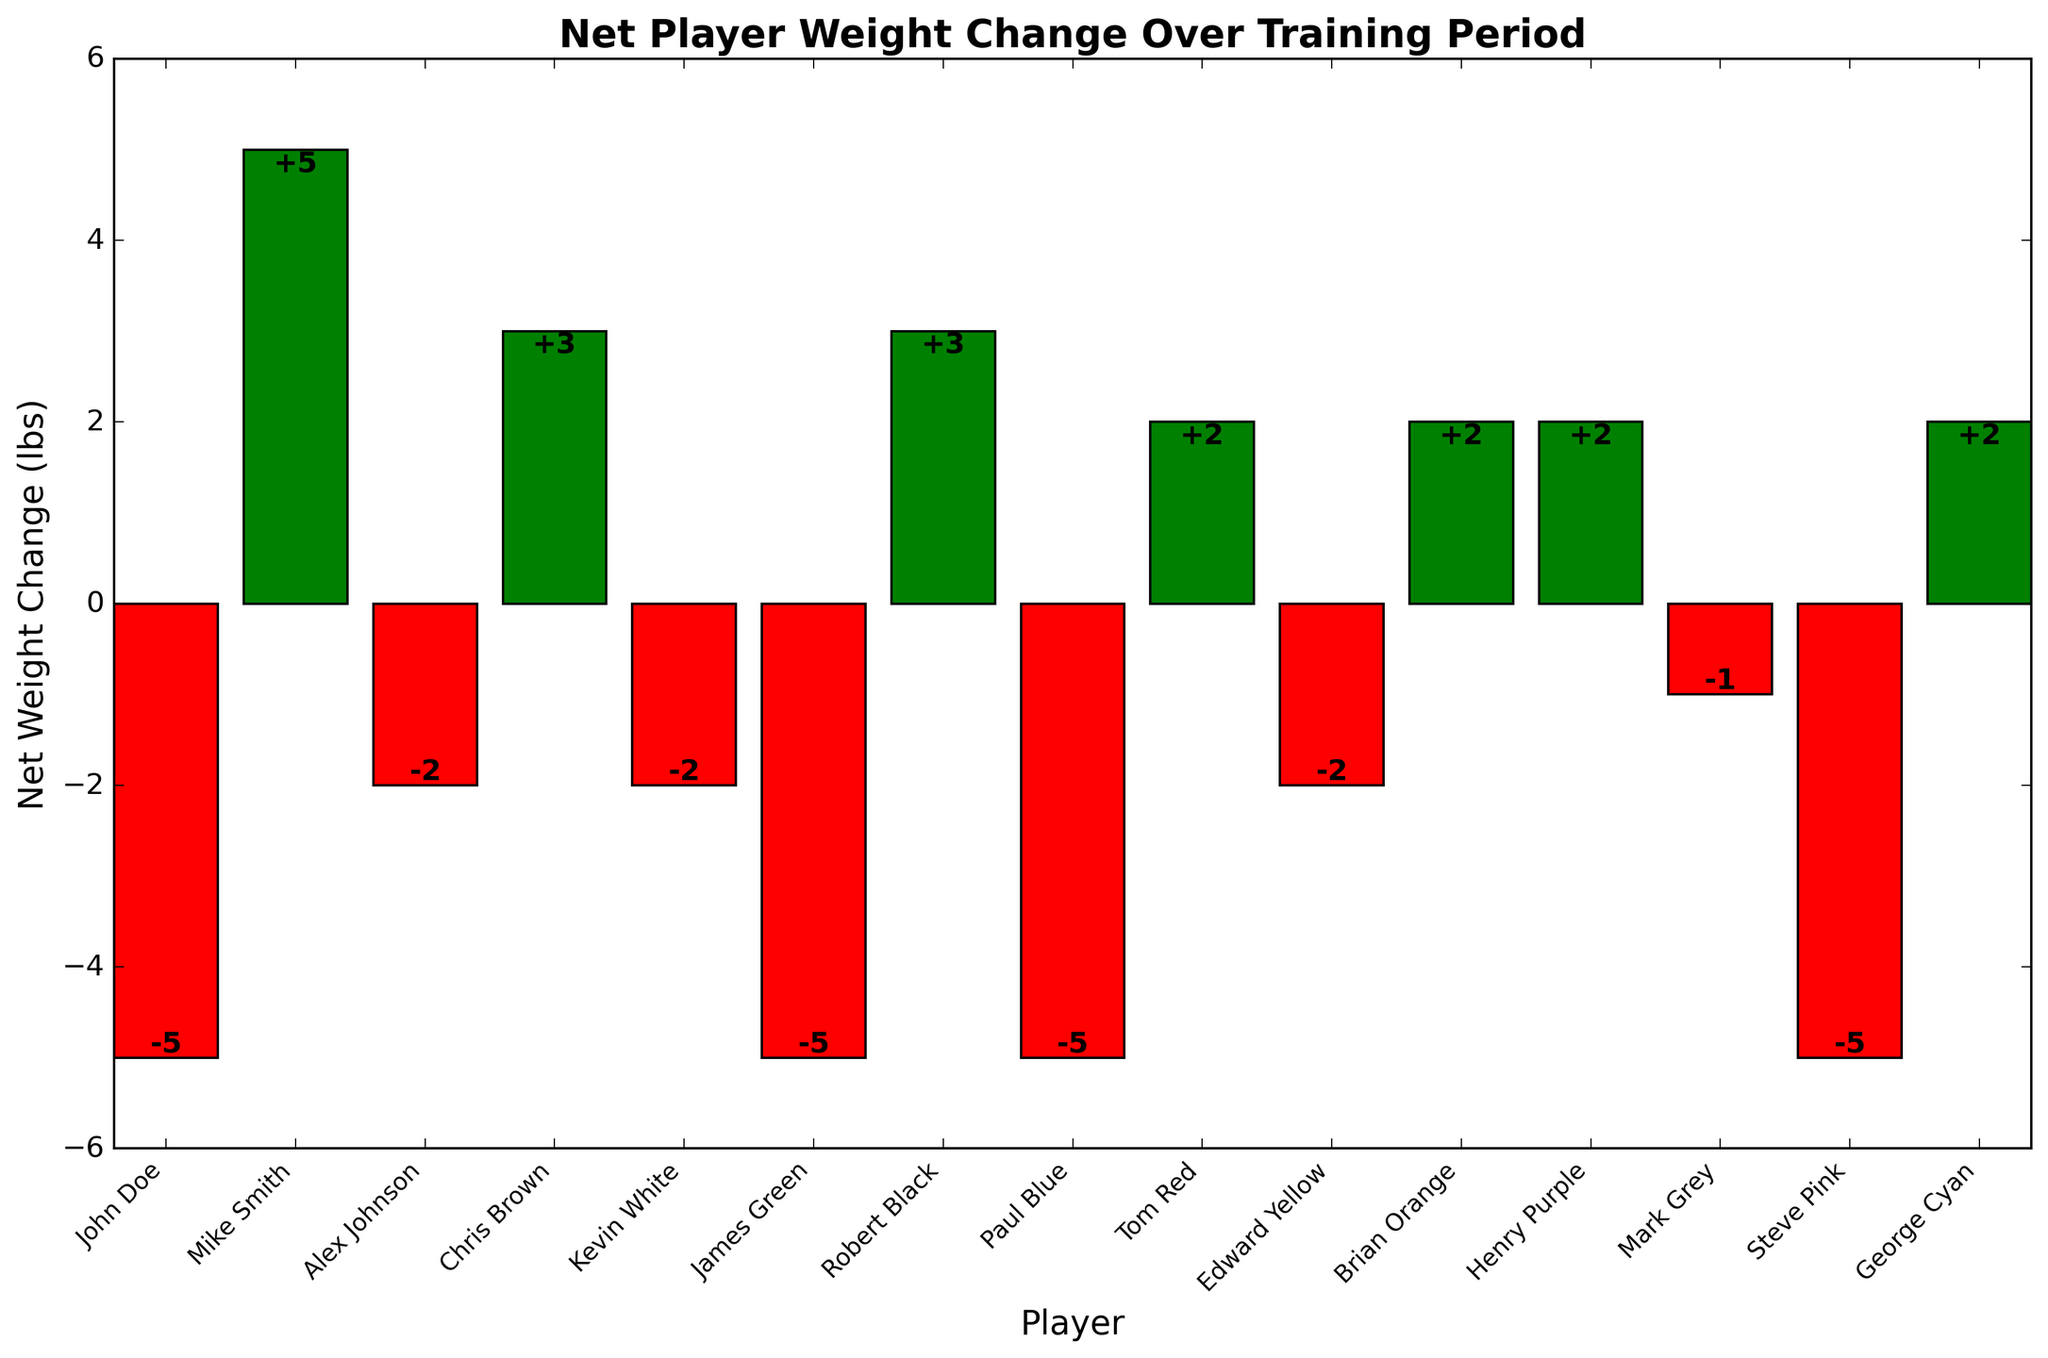Which player had the largest net weight increase? The figure shows the net weight changes for each player, with positive values indicating weight gain. The player with the tallest green bar has the largest net weight increase. Mike Smith has the tallest green bar.
Answer: Mike Smith How many players lost weight during the training period? Red bars indicate weight loss. By counting the number of red bars in the figure, we can determine the number of players who lost weight. There are 7 red bars, so 7 players lost weight.
Answer: 7 Which player had a net weight change of -5 lbs? The net weight changes are labeled on the bars. By identifying the bar labeled -5, we find the player associated with it. The bars labeled -5 are for John Doe, James Green, Paul Blue, and Steve Pink.
Answer: John Doe, James Green, Paul Blue, and Steve Pink What is the average net weight change for all players? Sum all the net weight changes and divide by the number of players. The total net weight change is (-5 + 5 - 2 + 3 - 2 - 5 + 3 - 5 + 2 - 2 + 2 + 2 - 1 - 5 + 2) = -12 lbs. There are 15 players. The average is -12/15 = -0.8 lbs.
Answer: -0.8 lbs Are there more players who gained weight or lost weight? Compare the number of green bars (weight gain) to the number of red bars (weight loss). There are 7 green bars and 7 red bars, so the number of players who gained weight equals the number of players who lost weight.
Answer: Equal Which player had the smallest net weight change? The smallest net weight change bar will be closest to the x-axis. The bar labeled -1 represents Mark Grey with the net weight change of -1.
Answer: Mark Grey How many players had a net weight change of exactly 2 lbs? The net weight changes are labeled on the bars. By counting the bars labeled 2 lbs, we find that there are 5 bars labeled 2 lbs.
Answer: 5 Which players had a net weight change between -3 lbs and 3 lbs (inclusive)? Examine the bars for heights between -3 and 3, inclusive, and list the corresponding players. Alex Johnson, Chris Brown, Kevin White, Tom Red, Edward Yellow, Brian Orange, Henry Purple, Mark Grey, and George Cyan fit this range.
Answer: Alex Johnson, Chris Brown, Kevin White, Tom Red, Edward Yellow, Brian Orange, Henry Purple, Mark Grey, George Cyan What is the net weight change for the three players with the highest initial weights combined? The three players with the highest initial weights are Paul Blue (220 lbs), Alex Johnson (210 lbs), and Tom Red (210 lbs). Their net weight changes are -5, -2, and +2, respectively. Sum these changes: -5 + (-2) + 2 = -5 lbs.
Answer: -5 lbs Which player had the largest net weight decrease? The figure shows the net weight changes for each player, with negative values indicating weight loss. The player with the lowest red bar has the largest net weight decrease. The player with the lowest red bar is John Doe with -5 lbs.
Answer: John Doe 